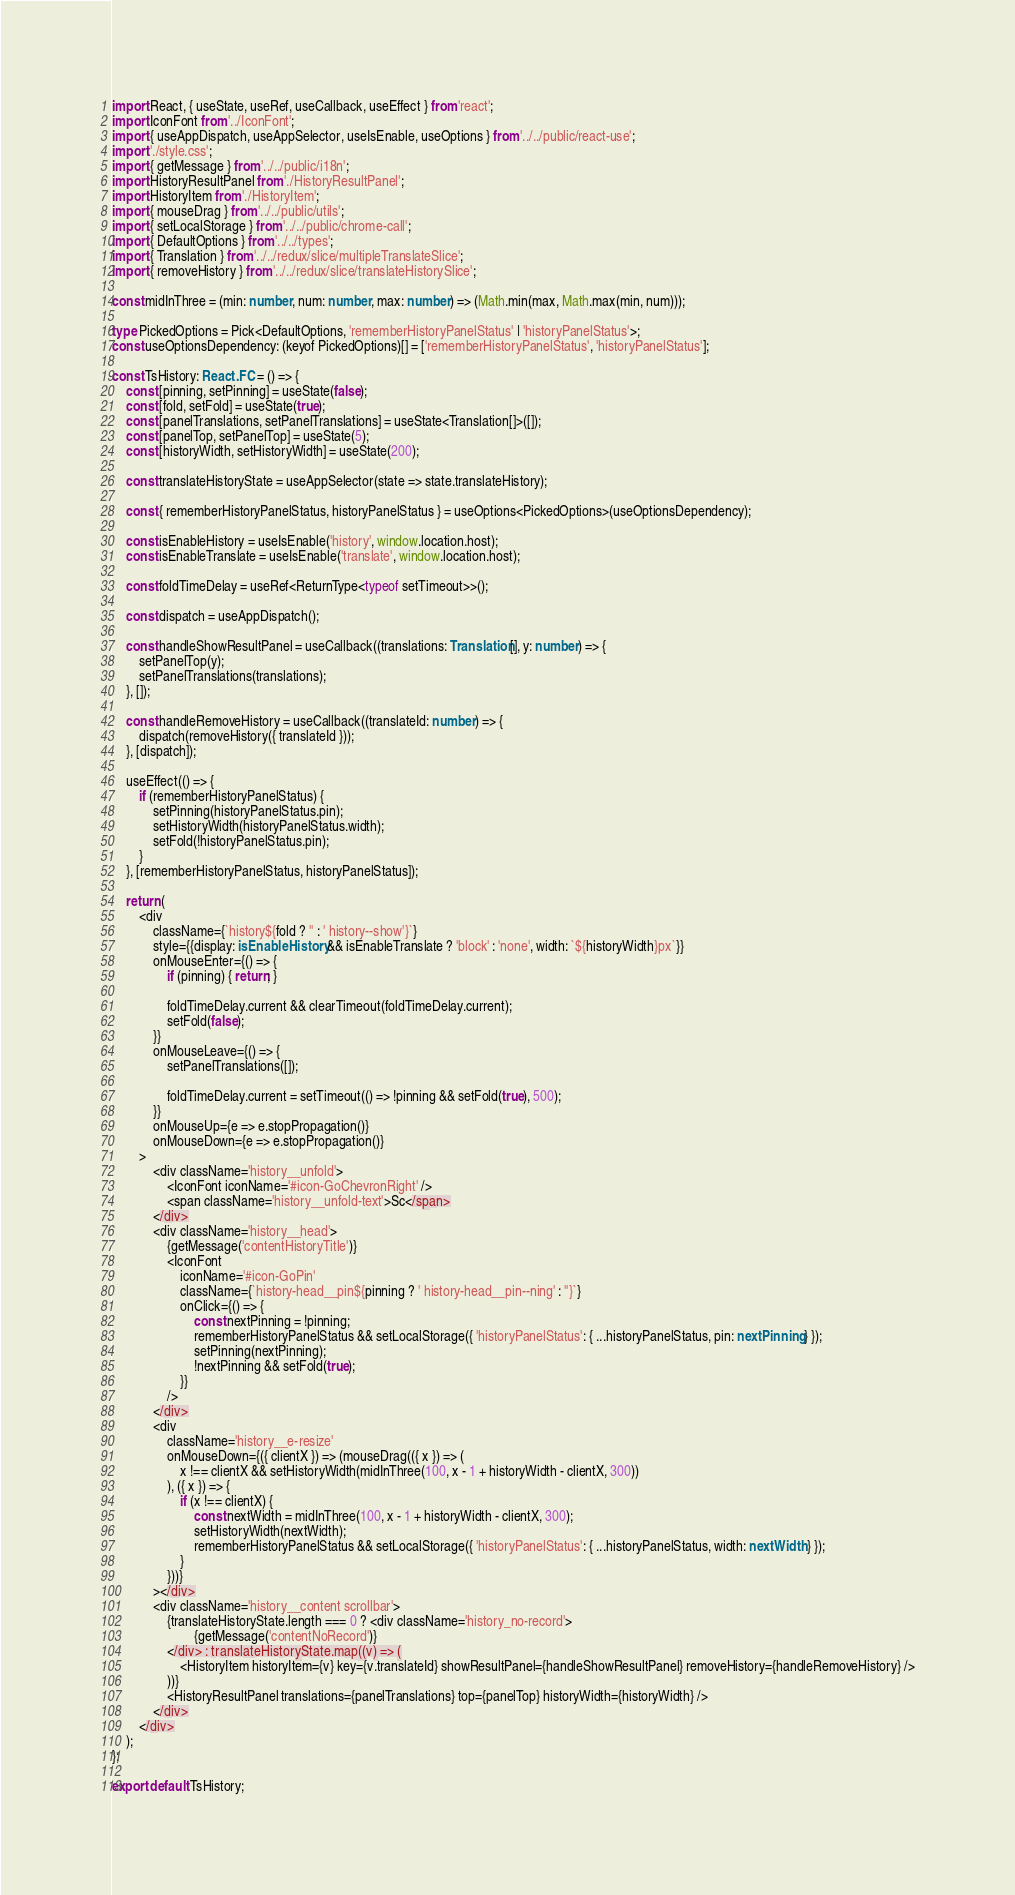<code> <loc_0><loc_0><loc_500><loc_500><_TypeScript_>import React, { useState, useRef, useCallback, useEffect } from 'react';
import IconFont from '../IconFont';
import { useAppDispatch, useAppSelector, useIsEnable, useOptions } from '../../public/react-use';
import './style.css';
import { getMessage } from '../../public/i18n';
import HistoryResultPanel from './HistoryResultPanel';
import HistoryItem from './HistoryItem';
import { mouseDrag } from '../../public/utils';
import { setLocalStorage } from '../../public/chrome-call';
import { DefaultOptions } from '../../types';
import { Translation } from '../../redux/slice/multipleTranslateSlice';
import { removeHistory } from '../../redux/slice/translateHistorySlice';

const midInThree = (min: number, num: number, max: number) => (Math.min(max, Math.max(min, num)));

type PickedOptions = Pick<DefaultOptions, 'rememberHistoryPanelStatus' | 'historyPanelStatus'>;
const useOptionsDependency: (keyof PickedOptions)[] = ['rememberHistoryPanelStatus', 'historyPanelStatus'];

const TsHistory: React.FC = () => {
    const [pinning, setPinning] = useState(false);
    const [fold, setFold] = useState(true);
    const [panelTranslations, setPanelTranslations] = useState<Translation[]>([]);
    const [panelTop, setPanelTop] = useState(5);
    const [historyWidth, setHistoryWidth] = useState(200);

    const translateHistoryState = useAppSelector(state => state.translateHistory);

    const { rememberHistoryPanelStatus, historyPanelStatus } = useOptions<PickedOptions>(useOptionsDependency);

    const isEnableHistory = useIsEnable('history', window.location.host);
    const isEnableTranslate = useIsEnable('translate', window.location.host);

    const foldTimeDelay = useRef<ReturnType<typeof setTimeout>>();

    const dispatch = useAppDispatch();

    const handleShowResultPanel = useCallback((translations: Translation[], y: number) => {
        setPanelTop(y);
        setPanelTranslations(translations);
    }, []);

    const handleRemoveHistory = useCallback((translateId: number) => {
        dispatch(removeHistory({ translateId }));
    }, [dispatch]);

    useEffect(() => {
        if (rememberHistoryPanelStatus) {
            setPinning(historyPanelStatus.pin);
            setHistoryWidth(historyPanelStatus.width);
            setFold(!historyPanelStatus.pin);
        }
    }, [rememberHistoryPanelStatus, historyPanelStatus]);

    return (
        <div
            className={`history${fold ? '' : ' history--show'}`}
            style={{display: isEnableHistory && isEnableTranslate ? 'block' : 'none', width: `${historyWidth}px`}}
            onMouseEnter={() => {
                if (pinning) { return; }

                foldTimeDelay.current && clearTimeout(foldTimeDelay.current);
                setFold(false);
            }}
            onMouseLeave={() => {
                setPanelTranslations([]);

                foldTimeDelay.current = setTimeout(() => !pinning && setFold(true), 500);
            }}
            onMouseUp={e => e.stopPropagation()}
            onMouseDown={e => e.stopPropagation()}
        >
            <div className='history__unfold'>
                <IconFont iconName='#icon-GoChevronRight' />
                <span className='history__unfold-text'>Sc</span>
            </div>
            <div className='history__head'>
                {getMessage('contentHistoryTitle')}
                <IconFont
                    iconName='#icon-GoPin'
                    className={`history-head__pin${pinning ? ' history-head__pin--ning' : ''}`}
                    onClick={() => {
                        const nextPinning = !pinning;
                        rememberHistoryPanelStatus && setLocalStorage({ 'historyPanelStatus': { ...historyPanelStatus, pin: nextPinning } });
                        setPinning(nextPinning);
                        !nextPinning && setFold(true);
                    }}
                />
            </div>
            <div
                className='history__e-resize'
                onMouseDown={({ clientX }) => (mouseDrag(({ x }) => (
                    x !== clientX && setHistoryWidth(midInThree(100, x - 1 + historyWidth - clientX, 300))
                ), ({ x }) => {
                    if (x !== clientX) {
                        const nextWidth = midInThree(100, x - 1 + historyWidth - clientX, 300);
                        setHistoryWidth(nextWidth);
                        rememberHistoryPanelStatus && setLocalStorage({ 'historyPanelStatus': { ...historyPanelStatus, width: nextWidth } });
                    }
                }))}
            ></div>
            <div className='history__content scrollbar'>
                {translateHistoryState.length === 0 ? <div className='history_no-record'>
                        {getMessage('contentNoRecord')}
                </div> : translateHistoryState.map((v) => (
                    <HistoryItem historyItem={v} key={v.translateId} showResultPanel={handleShowResultPanel} removeHistory={handleRemoveHistory} />
                ))}
                <HistoryResultPanel translations={panelTranslations} top={panelTop} historyWidth={historyWidth} />
            </div>
        </div>
    );
};

export default TsHistory;</code> 